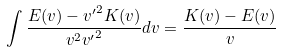Convert formula to latex. <formula><loc_0><loc_0><loc_500><loc_500>\int \frac { { E } ( v ) - { v ^ { \prime } } ^ { 2 } { K } ( v ) } { v ^ { 2 } { v ^ { \prime } } ^ { 2 } } d v = \frac { { K } ( v ) - { E } ( v ) } { v }</formula> 